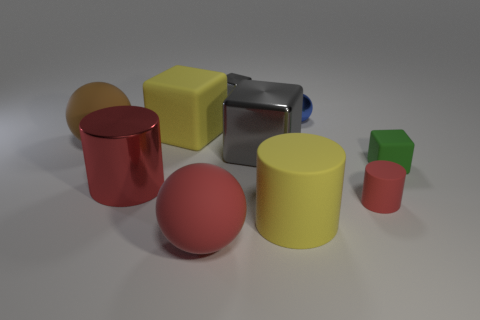Subtract all matte cylinders. How many cylinders are left? 1 Subtract all green cubes. How many cubes are left? 3 Subtract all blocks. How many objects are left? 6 Subtract all red cylinders. How many red balls are left? 1 Add 10 large purple shiny spheres. How many large purple shiny spheres exist? 10 Subtract 1 green cubes. How many objects are left? 9 Subtract 1 cylinders. How many cylinders are left? 2 Subtract all blue cylinders. Subtract all cyan blocks. How many cylinders are left? 3 Subtract all rubber cubes. Subtract all big red things. How many objects are left? 6 Add 4 matte things. How many matte things are left? 10 